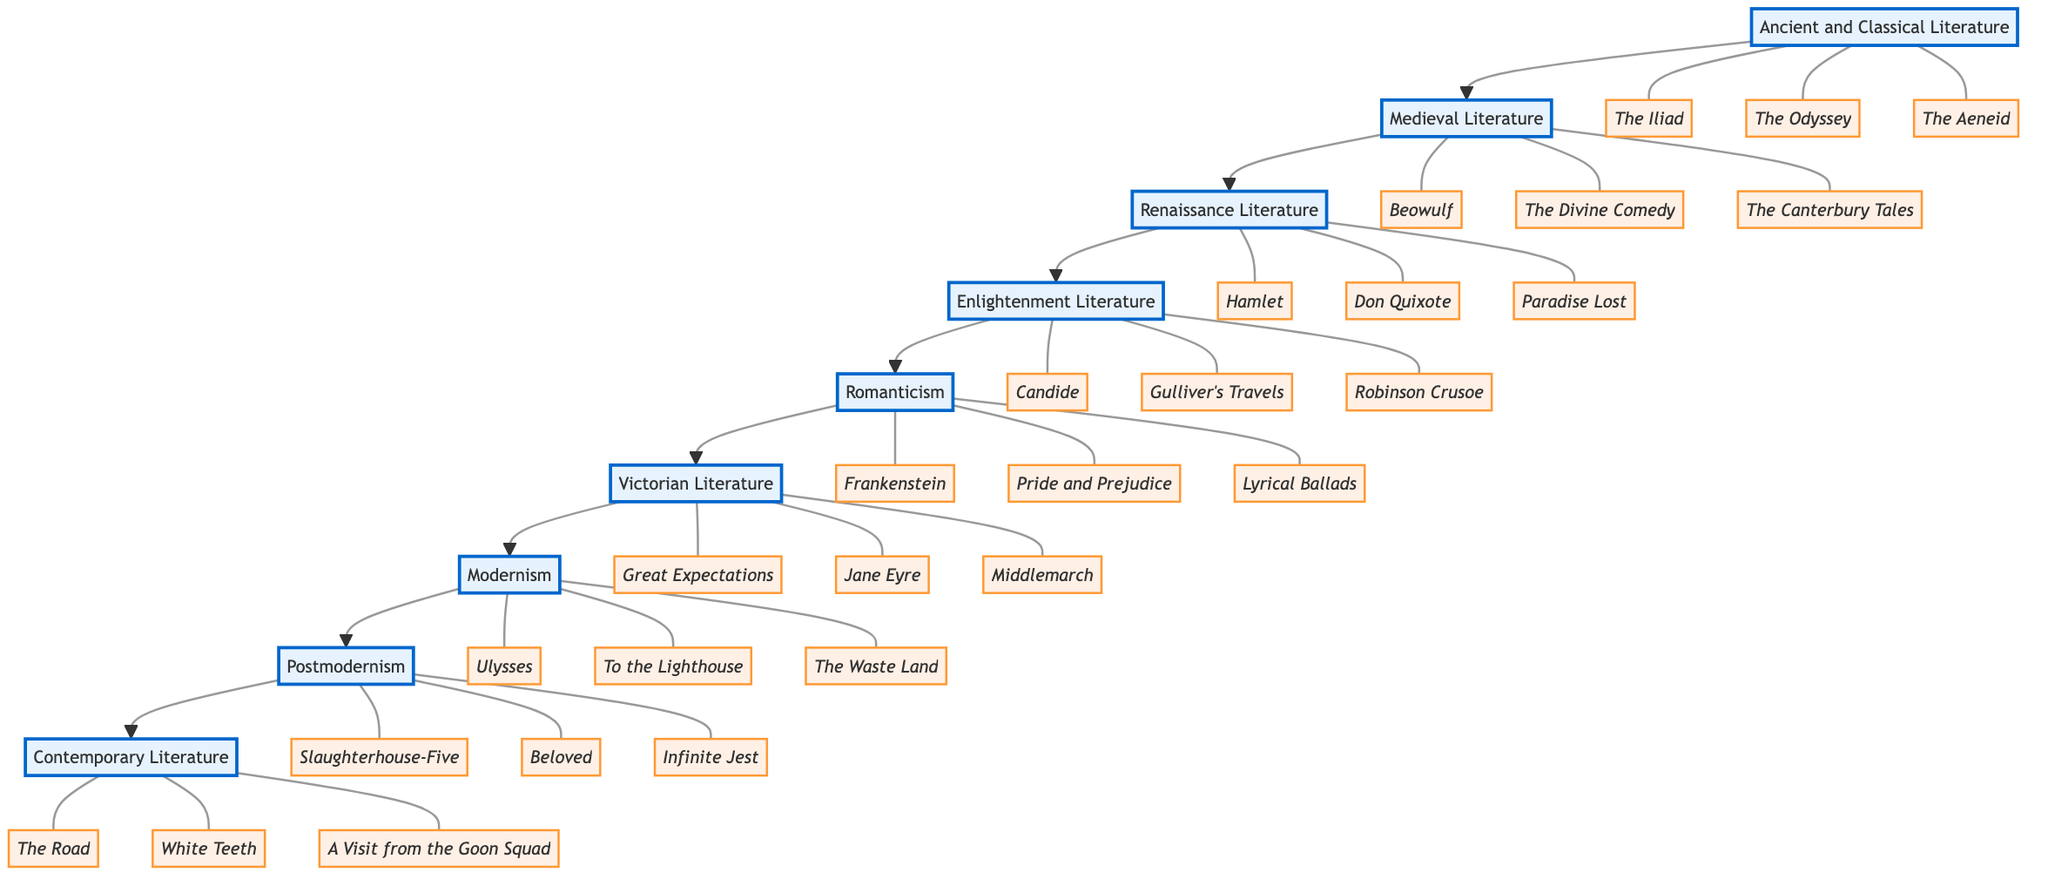What is the first genre listed in the diagram? The first genre block in the diagram is "Ancient and Classical Literature," as it is the starting point of the flowchart.
Answer: Ancient and Classical Literature How many influential works are associated with Romanticism? In the diagram, "Romanticism" has three influential works listed: "Frankenstein," "Pride and Prejudice," and "Lyrical Ballads." Counting these gives three works.
Answer: 3 What is the last genre in the flowchart? The last genre block in the flowchart is "Contemporary Literature." It is positioned at the end of the flow from Ancient and Classical Literature to Contemporary Literature.
Answer: Contemporary Literature Which genre comes after Victorian Literature? The diagram shows that the genre following "Victorian Literature" is "Modernism," indicating a direct connection in the sequence of literary genres.
Answer: Modernism List one influential work from Medieval Literature. From the "Medieval Literature" block, one influential work listed is "Beowulf." This is confirmed by examining the associated influential works of that genre.
Answer: Beowulf How many total genres are represented in the diagram? By counting the blocks in the flowchart, we identify a total of nine genres listed: Ancient and Classical Literature, Medieval Literature, Renaissance Literature, Enlightenment Literature, Romanticism, Victorian Literature, Modernism, Postmodernism, and Contemporary Literature.
Answer: 9 Which genre has "Ulysses" as an influential work? "Ulysses" is listed under the "Modernism" genre. This can be determined by tracing the connections and works associated with that particular genre block.
Answer: Modernism What genre is directly linked to Enlightenment Literature? The diagram indicates that the genre connected directly after "Enlightenment Literature" is "Romanticism," showing a clear sequence in the evolution of literary genres.
Answer: Romanticism Name the second influential work in Victorian Literature. The second influential work listed in the "Victorian Literature" block is "Jane Eyre," as it follows "Great Expectations" and precedes "Middlemarch" in the sequence of associated works.
Answer: Jane Eyre 